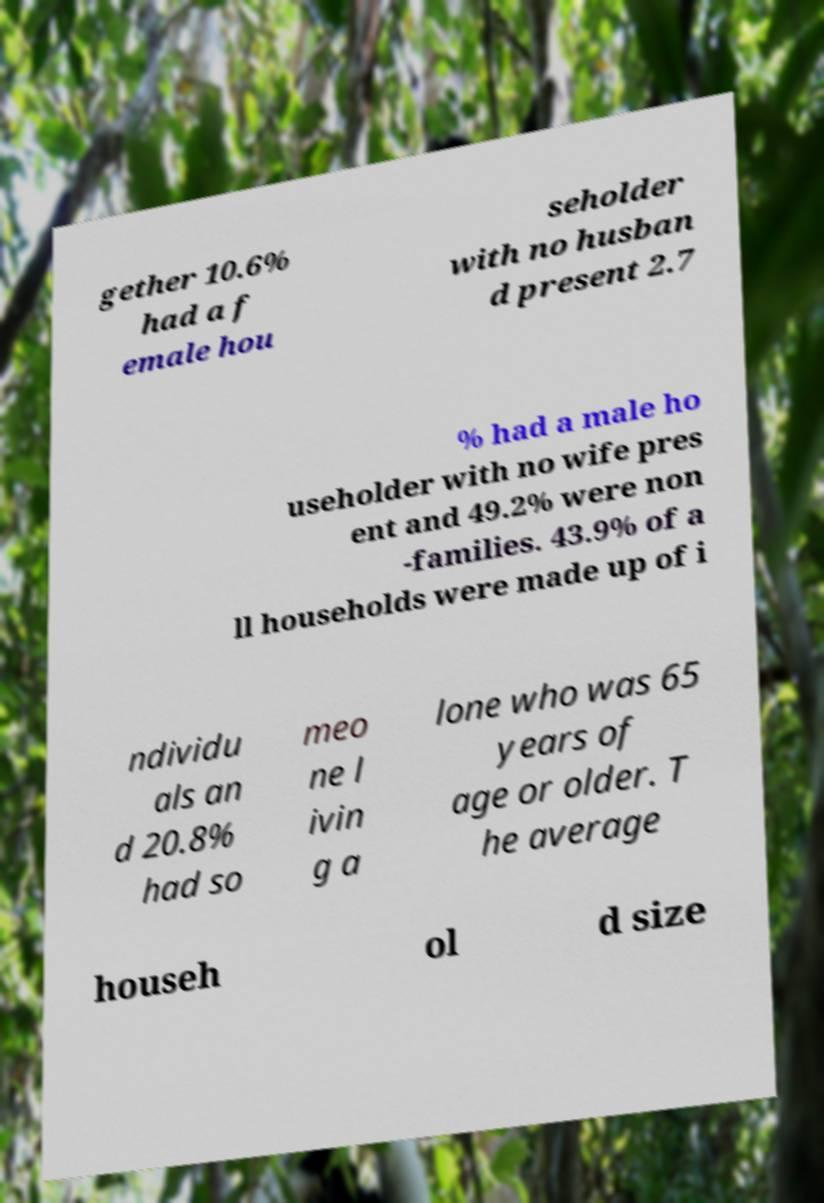Please read and relay the text visible in this image. What does it say? gether 10.6% had a f emale hou seholder with no husban d present 2.7 % had a male ho useholder with no wife pres ent and 49.2% were non -families. 43.9% of a ll households were made up of i ndividu als an d 20.8% had so meo ne l ivin g a lone who was 65 years of age or older. T he average househ ol d size 